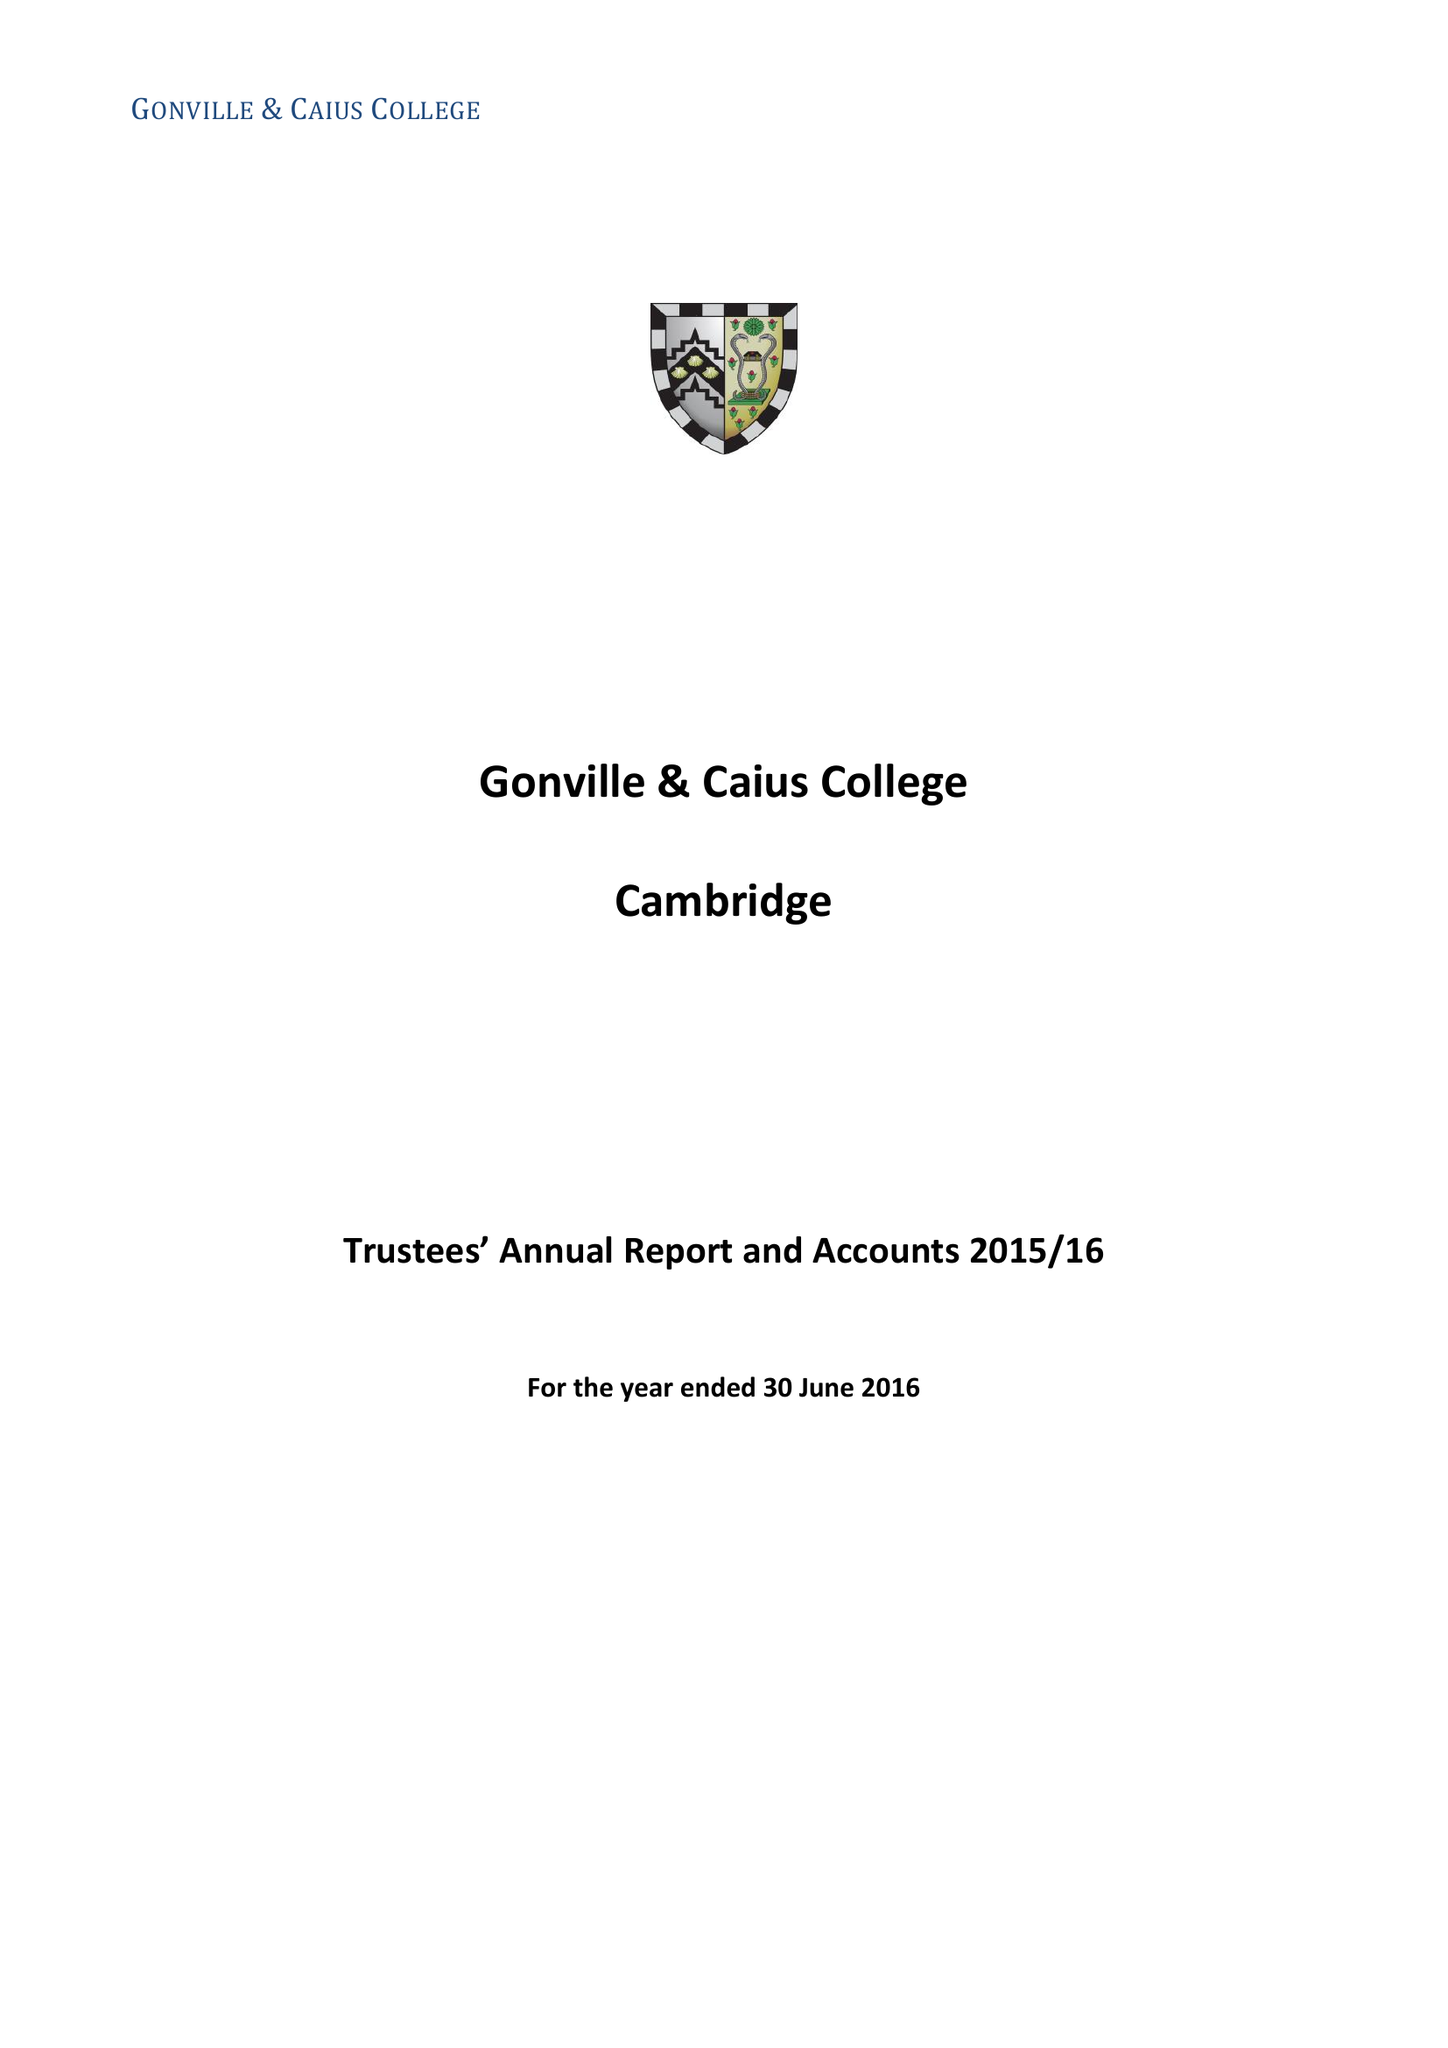What is the value for the spending_annually_in_british_pounds?
Answer the question using a single word or phrase. 15918868.00 